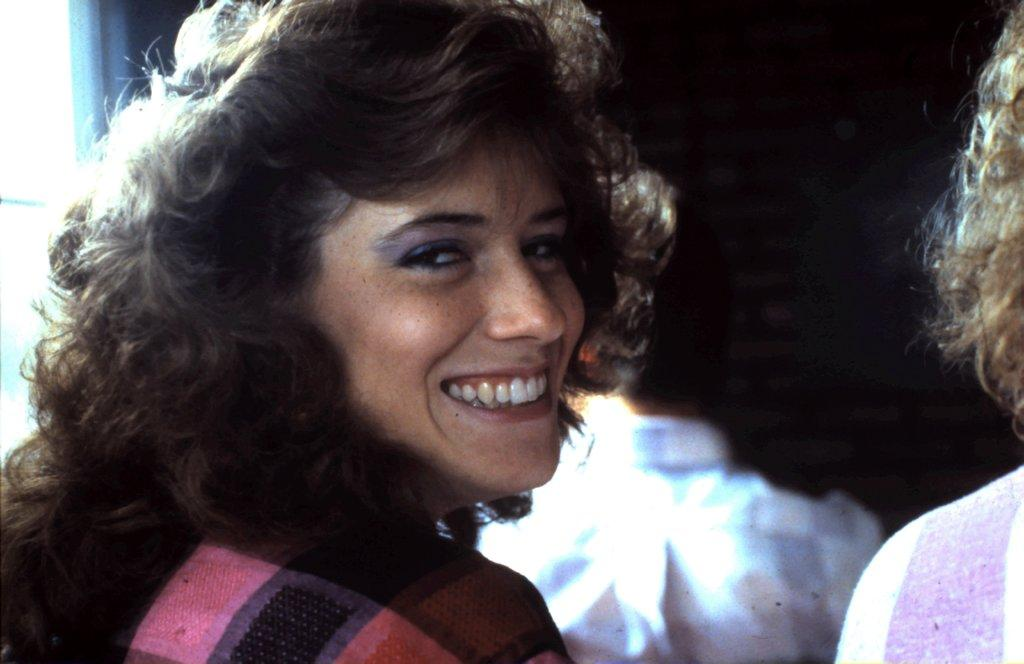What can be seen in the image? There is a group of people in the image. How are the people dressed? The people are wearing different color dresses. What color is the background of the image? The background of the image is black. What type of sponge is being used by the people in the image? There is no sponge present in the image; the people are wearing different color dresses. How are the people sorting items in the image? There is no indication in the image that the people are sorting items; they are simply standing together. 